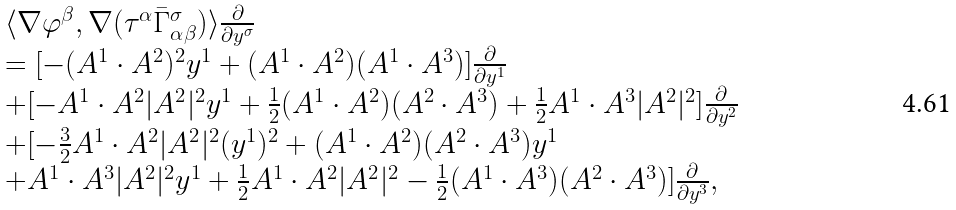Convert formula to latex. <formula><loc_0><loc_0><loc_500><loc_500>\begin{array} { l l l } \langle \nabla \varphi ^ { \beta } , \nabla ( \tau ^ { \alpha } { \bar { \Gamma } _ { \alpha \beta } ^ { \sigma } } ) \rangle \frac { \partial } { \partial y ^ { \sigma } } \\ = [ - ( A ^ { 1 } \cdot A ^ { 2 } ) ^ { 2 } y ^ { 1 } + ( A ^ { 1 } \cdot A ^ { 2 } ) ( A ^ { 1 } \cdot A ^ { 3 } ) ] \frac { \partial } { \partial y ^ { 1 } } \\ + [ - A ^ { 1 } \cdot A ^ { 2 } | A ^ { 2 } | ^ { 2 } y ^ { 1 } + \frac { 1 } { 2 } ( A ^ { 1 } \cdot A ^ { 2 } ) ( A ^ { 2 } \cdot A ^ { 3 } ) + \frac { 1 } { 2 } A ^ { 1 } \cdot A ^ { 3 } | A ^ { 2 } | ^ { 2 } ] \frac { \partial } { \partial y ^ { 2 } } \\ + [ - \frac { 3 } { 2 } A ^ { 1 } \cdot A ^ { 2 } | A ^ { 2 } | ^ { 2 } ( y ^ { 1 } ) ^ { 2 } + ( A ^ { 1 } \cdot A ^ { 2 } ) ( A ^ { 2 } \cdot A ^ { 3 } ) y ^ { 1 } \\ + A ^ { 1 } \cdot A ^ { 3 } | A ^ { 2 } | ^ { 2 } y ^ { 1 } + \frac { 1 } { 2 } A ^ { 1 } \cdot A ^ { 2 } | A ^ { 2 } | ^ { 2 } - \frac { 1 } { 2 } ( A ^ { 1 } \cdot A ^ { 3 } ) ( A ^ { 2 } \cdot A ^ { 3 } ) ] \frac { \partial } { \partial y ^ { 3 } } , \end{array}</formula> 